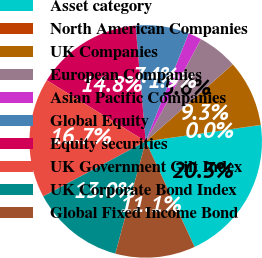<chart> <loc_0><loc_0><loc_500><loc_500><pie_chart><fcel>Asset category<fcel>North American Companies<fcel>UK Companies<fcel>European Companies<fcel>Asian Pacific Companies<fcel>Global Equity<fcel>Equity securities<fcel>UK Government Gilt Index<fcel>UK Corporate Bond Index<fcel>Global Fixed Income Bond<nl><fcel>20.34%<fcel>0.03%<fcel>9.26%<fcel>5.57%<fcel>1.87%<fcel>7.41%<fcel>14.8%<fcel>16.65%<fcel>12.95%<fcel>11.11%<nl></chart> 